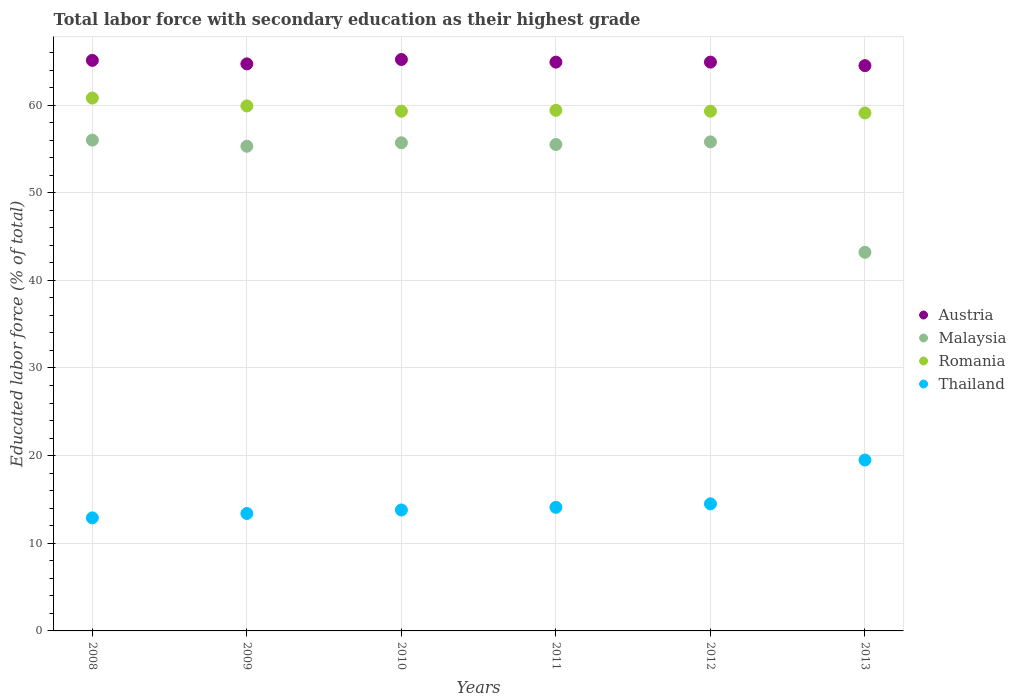How many different coloured dotlines are there?
Your answer should be very brief. 4. What is the percentage of total labor force with primary education in Thailand in 2013?
Keep it short and to the point. 19.5. Across all years, what is the maximum percentage of total labor force with primary education in Romania?
Ensure brevity in your answer.  60.8. Across all years, what is the minimum percentage of total labor force with primary education in Austria?
Offer a very short reply. 64.5. In which year was the percentage of total labor force with primary education in Austria minimum?
Provide a succinct answer. 2013. What is the total percentage of total labor force with primary education in Malaysia in the graph?
Give a very brief answer. 321.5. What is the difference between the percentage of total labor force with primary education in Thailand in 2008 and that in 2013?
Your answer should be compact. -6.6. What is the difference between the percentage of total labor force with primary education in Austria in 2011 and the percentage of total labor force with primary education in Thailand in 2008?
Give a very brief answer. 52. What is the average percentage of total labor force with primary education in Thailand per year?
Provide a short and direct response. 14.7. In the year 2012, what is the difference between the percentage of total labor force with primary education in Malaysia and percentage of total labor force with primary education in Thailand?
Offer a terse response. 41.3. What is the ratio of the percentage of total labor force with primary education in Malaysia in 2010 to that in 2012?
Your answer should be compact. 1. What is the difference between the highest and the second highest percentage of total labor force with primary education in Austria?
Offer a terse response. 0.1. What is the difference between the highest and the lowest percentage of total labor force with primary education in Romania?
Provide a succinct answer. 1.7. Is the sum of the percentage of total labor force with primary education in Romania in 2011 and 2012 greater than the maximum percentage of total labor force with primary education in Thailand across all years?
Offer a very short reply. Yes. Is it the case that in every year, the sum of the percentage of total labor force with primary education in Thailand and percentage of total labor force with primary education in Austria  is greater than the percentage of total labor force with primary education in Malaysia?
Your answer should be compact. Yes. Is the percentage of total labor force with primary education in Malaysia strictly greater than the percentage of total labor force with primary education in Austria over the years?
Your answer should be very brief. No. How many dotlines are there?
Provide a succinct answer. 4. How many legend labels are there?
Keep it short and to the point. 4. What is the title of the graph?
Give a very brief answer. Total labor force with secondary education as their highest grade. What is the label or title of the X-axis?
Make the answer very short. Years. What is the label or title of the Y-axis?
Provide a short and direct response. Educated labor force (% of total). What is the Educated labor force (% of total) of Austria in 2008?
Provide a succinct answer. 65.1. What is the Educated labor force (% of total) in Malaysia in 2008?
Your response must be concise. 56. What is the Educated labor force (% of total) of Romania in 2008?
Provide a succinct answer. 60.8. What is the Educated labor force (% of total) in Thailand in 2008?
Provide a succinct answer. 12.9. What is the Educated labor force (% of total) of Austria in 2009?
Your answer should be very brief. 64.7. What is the Educated labor force (% of total) in Malaysia in 2009?
Provide a succinct answer. 55.3. What is the Educated labor force (% of total) in Romania in 2009?
Ensure brevity in your answer.  59.9. What is the Educated labor force (% of total) of Thailand in 2009?
Offer a terse response. 13.4. What is the Educated labor force (% of total) of Austria in 2010?
Your answer should be compact. 65.2. What is the Educated labor force (% of total) of Malaysia in 2010?
Provide a short and direct response. 55.7. What is the Educated labor force (% of total) in Romania in 2010?
Provide a short and direct response. 59.3. What is the Educated labor force (% of total) of Thailand in 2010?
Your answer should be very brief. 13.8. What is the Educated labor force (% of total) of Austria in 2011?
Your response must be concise. 64.9. What is the Educated labor force (% of total) of Malaysia in 2011?
Ensure brevity in your answer.  55.5. What is the Educated labor force (% of total) of Romania in 2011?
Offer a terse response. 59.4. What is the Educated labor force (% of total) of Thailand in 2011?
Provide a short and direct response. 14.1. What is the Educated labor force (% of total) in Austria in 2012?
Ensure brevity in your answer.  64.9. What is the Educated labor force (% of total) of Malaysia in 2012?
Offer a terse response. 55.8. What is the Educated labor force (% of total) in Romania in 2012?
Keep it short and to the point. 59.3. What is the Educated labor force (% of total) in Austria in 2013?
Your answer should be very brief. 64.5. What is the Educated labor force (% of total) in Malaysia in 2013?
Your answer should be compact. 43.2. What is the Educated labor force (% of total) of Romania in 2013?
Give a very brief answer. 59.1. What is the Educated labor force (% of total) of Thailand in 2013?
Provide a short and direct response. 19.5. Across all years, what is the maximum Educated labor force (% of total) of Austria?
Your response must be concise. 65.2. Across all years, what is the maximum Educated labor force (% of total) of Romania?
Your answer should be compact. 60.8. Across all years, what is the maximum Educated labor force (% of total) of Thailand?
Offer a terse response. 19.5. Across all years, what is the minimum Educated labor force (% of total) in Austria?
Keep it short and to the point. 64.5. Across all years, what is the minimum Educated labor force (% of total) of Malaysia?
Provide a short and direct response. 43.2. Across all years, what is the minimum Educated labor force (% of total) in Romania?
Give a very brief answer. 59.1. Across all years, what is the minimum Educated labor force (% of total) of Thailand?
Your answer should be very brief. 12.9. What is the total Educated labor force (% of total) in Austria in the graph?
Your response must be concise. 389.3. What is the total Educated labor force (% of total) in Malaysia in the graph?
Provide a succinct answer. 321.5. What is the total Educated labor force (% of total) in Romania in the graph?
Give a very brief answer. 357.8. What is the total Educated labor force (% of total) in Thailand in the graph?
Keep it short and to the point. 88.2. What is the difference between the Educated labor force (% of total) of Malaysia in 2008 and that in 2009?
Your answer should be compact. 0.7. What is the difference between the Educated labor force (% of total) of Austria in 2008 and that in 2010?
Offer a very short reply. -0.1. What is the difference between the Educated labor force (% of total) in Austria in 2008 and that in 2011?
Give a very brief answer. 0.2. What is the difference between the Educated labor force (% of total) of Malaysia in 2008 and that in 2011?
Offer a terse response. 0.5. What is the difference between the Educated labor force (% of total) in Austria in 2008 and that in 2012?
Offer a very short reply. 0.2. What is the difference between the Educated labor force (% of total) in Romania in 2008 and that in 2012?
Your answer should be very brief. 1.5. What is the difference between the Educated labor force (% of total) in Austria in 2008 and that in 2013?
Your answer should be compact. 0.6. What is the difference between the Educated labor force (% of total) of Malaysia in 2008 and that in 2013?
Make the answer very short. 12.8. What is the difference between the Educated labor force (% of total) in Romania in 2009 and that in 2010?
Ensure brevity in your answer.  0.6. What is the difference between the Educated labor force (% of total) in Austria in 2009 and that in 2011?
Provide a short and direct response. -0.2. What is the difference between the Educated labor force (% of total) in Malaysia in 2009 and that in 2011?
Your response must be concise. -0.2. What is the difference between the Educated labor force (% of total) of Thailand in 2009 and that in 2011?
Offer a terse response. -0.7. What is the difference between the Educated labor force (% of total) of Malaysia in 2009 and that in 2012?
Offer a terse response. -0.5. What is the difference between the Educated labor force (% of total) of Austria in 2009 and that in 2013?
Offer a very short reply. 0.2. What is the difference between the Educated labor force (% of total) in Romania in 2009 and that in 2013?
Provide a short and direct response. 0.8. What is the difference between the Educated labor force (% of total) of Thailand in 2009 and that in 2013?
Make the answer very short. -6.1. What is the difference between the Educated labor force (% of total) of Romania in 2010 and that in 2011?
Keep it short and to the point. -0.1. What is the difference between the Educated labor force (% of total) in Thailand in 2010 and that in 2011?
Offer a terse response. -0.3. What is the difference between the Educated labor force (% of total) of Romania in 2010 and that in 2012?
Ensure brevity in your answer.  0. What is the difference between the Educated labor force (% of total) in Austria in 2010 and that in 2013?
Provide a short and direct response. 0.7. What is the difference between the Educated labor force (% of total) of Malaysia in 2010 and that in 2013?
Provide a succinct answer. 12.5. What is the difference between the Educated labor force (% of total) in Austria in 2011 and that in 2012?
Your response must be concise. 0. What is the difference between the Educated labor force (% of total) of Malaysia in 2011 and that in 2012?
Your response must be concise. -0.3. What is the difference between the Educated labor force (% of total) of Thailand in 2011 and that in 2012?
Make the answer very short. -0.4. What is the difference between the Educated labor force (% of total) of Austria in 2011 and that in 2013?
Your answer should be very brief. 0.4. What is the difference between the Educated labor force (% of total) in Malaysia in 2011 and that in 2013?
Provide a succinct answer. 12.3. What is the difference between the Educated labor force (% of total) of Thailand in 2011 and that in 2013?
Provide a short and direct response. -5.4. What is the difference between the Educated labor force (% of total) in Austria in 2008 and the Educated labor force (% of total) in Thailand in 2009?
Give a very brief answer. 51.7. What is the difference between the Educated labor force (% of total) of Malaysia in 2008 and the Educated labor force (% of total) of Romania in 2009?
Keep it short and to the point. -3.9. What is the difference between the Educated labor force (% of total) in Malaysia in 2008 and the Educated labor force (% of total) in Thailand in 2009?
Your answer should be very brief. 42.6. What is the difference between the Educated labor force (% of total) in Romania in 2008 and the Educated labor force (% of total) in Thailand in 2009?
Provide a short and direct response. 47.4. What is the difference between the Educated labor force (% of total) in Austria in 2008 and the Educated labor force (% of total) in Romania in 2010?
Your answer should be very brief. 5.8. What is the difference between the Educated labor force (% of total) in Austria in 2008 and the Educated labor force (% of total) in Thailand in 2010?
Offer a terse response. 51.3. What is the difference between the Educated labor force (% of total) in Malaysia in 2008 and the Educated labor force (% of total) in Romania in 2010?
Offer a very short reply. -3.3. What is the difference between the Educated labor force (% of total) of Malaysia in 2008 and the Educated labor force (% of total) of Thailand in 2010?
Ensure brevity in your answer.  42.2. What is the difference between the Educated labor force (% of total) in Austria in 2008 and the Educated labor force (% of total) in Malaysia in 2011?
Your answer should be very brief. 9.6. What is the difference between the Educated labor force (% of total) in Austria in 2008 and the Educated labor force (% of total) in Romania in 2011?
Give a very brief answer. 5.7. What is the difference between the Educated labor force (% of total) in Malaysia in 2008 and the Educated labor force (% of total) in Thailand in 2011?
Give a very brief answer. 41.9. What is the difference between the Educated labor force (% of total) of Romania in 2008 and the Educated labor force (% of total) of Thailand in 2011?
Offer a terse response. 46.7. What is the difference between the Educated labor force (% of total) of Austria in 2008 and the Educated labor force (% of total) of Romania in 2012?
Your answer should be very brief. 5.8. What is the difference between the Educated labor force (% of total) of Austria in 2008 and the Educated labor force (% of total) of Thailand in 2012?
Your answer should be very brief. 50.6. What is the difference between the Educated labor force (% of total) in Malaysia in 2008 and the Educated labor force (% of total) in Thailand in 2012?
Your response must be concise. 41.5. What is the difference between the Educated labor force (% of total) in Romania in 2008 and the Educated labor force (% of total) in Thailand in 2012?
Your response must be concise. 46.3. What is the difference between the Educated labor force (% of total) of Austria in 2008 and the Educated labor force (% of total) of Malaysia in 2013?
Your answer should be compact. 21.9. What is the difference between the Educated labor force (% of total) in Austria in 2008 and the Educated labor force (% of total) in Thailand in 2013?
Offer a terse response. 45.6. What is the difference between the Educated labor force (% of total) in Malaysia in 2008 and the Educated labor force (% of total) in Romania in 2013?
Offer a very short reply. -3.1. What is the difference between the Educated labor force (% of total) of Malaysia in 2008 and the Educated labor force (% of total) of Thailand in 2013?
Ensure brevity in your answer.  36.5. What is the difference between the Educated labor force (% of total) in Romania in 2008 and the Educated labor force (% of total) in Thailand in 2013?
Offer a terse response. 41.3. What is the difference between the Educated labor force (% of total) of Austria in 2009 and the Educated labor force (% of total) of Thailand in 2010?
Your answer should be very brief. 50.9. What is the difference between the Educated labor force (% of total) in Malaysia in 2009 and the Educated labor force (% of total) in Thailand in 2010?
Your response must be concise. 41.5. What is the difference between the Educated labor force (% of total) of Romania in 2009 and the Educated labor force (% of total) of Thailand in 2010?
Provide a succinct answer. 46.1. What is the difference between the Educated labor force (% of total) in Austria in 2009 and the Educated labor force (% of total) in Thailand in 2011?
Ensure brevity in your answer.  50.6. What is the difference between the Educated labor force (% of total) of Malaysia in 2009 and the Educated labor force (% of total) of Romania in 2011?
Provide a succinct answer. -4.1. What is the difference between the Educated labor force (% of total) of Malaysia in 2009 and the Educated labor force (% of total) of Thailand in 2011?
Your answer should be very brief. 41.2. What is the difference between the Educated labor force (% of total) of Romania in 2009 and the Educated labor force (% of total) of Thailand in 2011?
Keep it short and to the point. 45.8. What is the difference between the Educated labor force (% of total) of Austria in 2009 and the Educated labor force (% of total) of Malaysia in 2012?
Your answer should be very brief. 8.9. What is the difference between the Educated labor force (% of total) of Austria in 2009 and the Educated labor force (% of total) of Thailand in 2012?
Ensure brevity in your answer.  50.2. What is the difference between the Educated labor force (% of total) of Malaysia in 2009 and the Educated labor force (% of total) of Thailand in 2012?
Offer a very short reply. 40.8. What is the difference between the Educated labor force (% of total) in Romania in 2009 and the Educated labor force (% of total) in Thailand in 2012?
Your response must be concise. 45.4. What is the difference between the Educated labor force (% of total) of Austria in 2009 and the Educated labor force (% of total) of Thailand in 2013?
Ensure brevity in your answer.  45.2. What is the difference between the Educated labor force (% of total) of Malaysia in 2009 and the Educated labor force (% of total) of Romania in 2013?
Keep it short and to the point. -3.8. What is the difference between the Educated labor force (% of total) in Malaysia in 2009 and the Educated labor force (% of total) in Thailand in 2013?
Give a very brief answer. 35.8. What is the difference between the Educated labor force (% of total) in Romania in 2009 and the Educated labor force (% of total) in Thailand in 2013?
Offer a terse response. 40.4. What is the difference between the Educated labor force (% of total) of Austria in 2010 and the Educated labor force (% of total) of Thailand in 2011?
Your response must be concise. 51.1. What is the difference between the Educated labor force (% of total) of Malaysia in 2010 and the Educated labor force (% of total) of Thailand in 2011?
Make the answer very short. 41.6. What is the difference between the Educated labor force (% of total) in Romania in 2010 and the Educated labor force (% of total) in Thailand in 2011?
Your answer should be very brief. 45.2. What is the difference between the Educated labor force (% of total) in Austria in 2010 and the Educated labor force (% of total) in Thailand in 2012?
Make the answer very short. 50.7. What is the difference between the Educated labor force (% of total) of Malaysia in 2010 and the Educated labor force (% of total) of Thailand in 2012?
Make the answer very short. 41.2. What is the difference between the Educated labor force (% of total) of Romania in 2010 and the Educated labor force (% of total) of Thailand in 2012?
Give a very brief answer. 44.8. What is the difference between the Educated labor force (% of total) of Austria in 2010 and the Educated labor force (% of total) of Romania in 2013?
Keep it short and to the point. 6.1. What is the difference between the Educated labor force (% of total) in Austria in 2010 and the Educated labor force (% of total) in Thailand in 2013?
Keep it short and to the point. 45.7. What is the difference between the Educated labor force (% of total) of Malaysia in 2010 and the Educated labor force (% of total) of Thailand in 2013?
Offer a terse response. 36.2. What is the difference between the Educated labor force (% of total) of Romania in 2010 and the Educated labor force (% of total) of Thailand in 2013?
Offer a terse response. 39.8. What is the difference between the Educated labor force (% of total) in Austria in 2011 and the Educated labor force (% of total) in Malaysia in 2012?
Keep it short and to the point. 9.1. What is the difference between the Educated labor force (% of total) in Austria in 2011 and the Educated labor force (% of total) in Thailand in 2012?
Your answer should be compact. 50.4. What is the difference between the Educated labor force (% of total) in Romania in 2011 and the Educated labor force (% of total) in Thailand in 2012?
Give a very brief answer. 44.9. What is the difference between the Educated labor force (% of total) of Austria in 2011 and the Educated labor force (% of total) of Malaysia in 2013?
Keep it short and to the point. 21.7. What is the difference between the Educated labor force (% of total) in Austria in 2011 and the Educated labor force (% of total) in Thailand in 2013?
Give a very brief answer. 45.4. What is the difference between the Educated labor force (% of total) in Romania in 2011 and the Educated labor force (% of total) in Thailand in 2013?
Your answer should be compact. 39.9. What is the difference between the Educated labor force (% of total) in Austria in 2012 and the Educated labor force (% of total) in Malaysia in 2013?
Offer a terse response. 21.7. What is the difference between the Educated labor force (% of total) of Austria in 2012 and the Educated labor force (% of total) of Romania in 2013?
Your answer should be very brief. 5.8. What is the difference between the Educated labor force (% of total) in Austria in 2012 and the Educated labor force (% of total) in Thailand in 2013?
Make the answer very short. 45.4. What is the difference between the Educated labor force (% of total) of Malaysia in 2012 and the Educated labor force (% of total) of Romania in 2013?
Your answer should be compact. -3.3. What is the difference between the Educated labor force (% of total) of Malaysia in 2012 and the Educated labor force (% of total) of Thailand in 2013?
Offer a very short reply. 36.3. What is the difference between the Educated labor force (% of total) of Romania in 2012 and the Educated labor force (% of total) of Thailand in 2013?
Provide a succinct answer. 39.8. What is the average Educated labor force (% of total) of Austria per year?
Make the answer very short. 64.88. What is the average Educated labor force (% of total) of Malaysia per year?
Make the answer very short. 53.58. What is the average Educated labor force (% of total) of Romania per year?
Give a very brief answer. 59.63. In the year 2008, what is the difference between the Educated labor force (% of total) of Austria and Educated labor force (% of total) of Malaysia?
Keep it short and to the point. 9.1. In the year 2008, what is the difference between the Educated labor force (% of total) of Austria and Educated labor force (% of total) of Romania?
Your answer should be compact. 4.3. In the year 2008, what is the difference between the Educated labor force (% of total) in Austria and Educated labor force (% of total) in Thailand?
Your answer should be compact. 52.2. In the year 2008, what is the difference between the Educated labor force (% of total) of Malaysia and Educated labor force (% of total) of Romania?
Ensure brevity in your answer.  -4.8. In the year 2008, what is the difference between the Educated labor force (% of total) of Malaysia and Educated labor force (% of total) of Thailand?
Provide a succinct answer. 43.1. In the year 2008, what is the difference between the Educated labor force (% of total) of Romania and Educated labor force (% of total) of Thailand?
Offer a terse response. 47.9. In the year 2009, what is the difference between the Educated labor force (% of total) in Austria and Educated labor force (% of total) in Romania?
Offer a terse response. 4.8. In the year 2009, what is the difference between the Educated labor force (% of total) of Austria and Educated labor force (% of total) of Thailand?
Keep it short and to the point. 51.3. In the year 2009, what is the difference between the Educated labor force (% of total) in Malaysia and Educated labor force (% of total) in Thailand?
Offer a terse response. 41.9. In the year 2009, what is the difference between the Educated labor force (% of total) of Romania and Educated labor force (% of total) of Thailand?
Your answer should be compact. 46.5. In the year 2010, what is the difference between the Educated labor force (% of total) in Austria and Educated labor force (% of total) in Malaysia?
Give a very brief answer. 9.5. In the year 2010, what is the difference between the Educated labor force (% of total) in Austria and Educated labor force (% of total) in Romania?
Provide a succinct answer. 5.9. In the year 2010, what is the difference between the Educated labor force (% of total) of Austria and Educated labor force (% of total) of Thailand?
Your answer should be very brief. 51.4. In the year 2010, what is the difference between the Educated labor force (% of total) in Malaysia and Educated labor force (% of total) in Romania?
Keep it short and to the point. -3.6. In the year 2010, what is the difference between the Educated labor force (% of total) of Malaysia and Educated labor force (% of total) of Thailand?
Offer a very short reply. 41.9. In the year 2010, what is the difference between the Educated labor force (% of total) of Romania and Educated labor force (% of total) of Thailand?
Provide a succinct answer. 45.5. In the year 2011, what is the difference between the Educated labor force (% of total) of Austria and Educated labor force (% of total) of Romania?
Provide a short and direct response. 5.5. In the year 2011, what is the difference between the Educated labor force (% of total) of Austria and Educated labor force (% of total) of Thailand?
Give a very brief answer. 50.8. In the year 2011, what is the difference between the Educated labor force (% of total) of Malaysia and Educated labor force (% of total) of Thailand?
Your response must be concise. 41.4. In the year 2011, what is the difference between the Educated labor force (% of total) of Romania and Educated labor force (% of total) of Thailand?
Ensure brevity in your answer.  45.3. In the year 2012, what is the difference between the Educated labor force (% of total) in Austria and Educated labor force (% of total) in Malaysia?
Offer a very short reply. 9.1. In the year 2012, what is the difference between the Educated labor force (% of total) of Austria and Educated labor force (% of total) of Romania?
Your answer should be very brief. 5.6. In the year 2012, what is the difference between the Educated labor force (% of total) of Austria and Educated labor force (% of total) of Thailand?
Make the answer very short. 50.4. In the year 2012, what is the difference between the Educated labor force (% of total) in Malaysia and Educated labor force (% of total) in Romania?
Your answer should be very brief. -3.5. In the year 2012, what is the difference between the Educated labor force (% of total) of Malaysia and Educated labor force (% of total) of Thailand?
Keep it short and to the point. 41.3. In the year 2012, what is the difference between the Educated labor force (% of total) of Romania and Educated labor force (% of total) of Thailand?
Your answer should be compact. 44.8. In the year 2013, what is the difference between the Educated labor force (% of total) of Austria and Educated labor force (% of total) of Malaysia?
Your answer should be very brief. 21.3. In the year 2013, what is the difference between the Educated labor force (% of total) of Austria and Educated labor force (% of total) of Thailand?
Give a very brief answer. 45. In the year 2013, what is the difference between the Educated labor force (% of total) of Malaysia and Educated labor force (% of total) of Romania?
Offer a very short reply. -15.9. In the year 2013, what is the difference between the Educated labor force (% of total) of Malaysia and Educated labor force (% of total) of Thailand?
Give a very brief answer. 23.7. In the year 2013, what is the difference between the Educated labor force (% of total) of Romania and Educated labor force (% of total) of Thailand?
Provide a succinct answer. 39.6. What is the ratio of the Educated labor force (% of total) in Malaysia in 2008 to that in 2009?
Your response must be concise. 1.01. What is the ratio of the Educated labor force (% of total) in Romania in 2008 to that in 2009?
Give a very brief answer. 1.01. What is the ratio of the Educated labor force (% of total) in Thailand in 2008 to that in 2009?
Provide a succinct answer. 0.96. What is the ratio of the Educated labor force (% of total) of Austria in 2008 to that in 2010?
Provide a short and direct response. 1. What is the ratio of the Educated labor force (% of total) in Malaysia in 2008 to that in 2010?
Make the answer very short. 1.01. What is the ratio of the Educated labor force (% of total) of Romania in 2008 to that in 2010?
Your answer should be very brief. 1.03. What is the ratio of the Educated labor force (% of total) in Thailand in 2008 to that in 2010?
Keep it short and to the point. 0.93. What is the ratio of the Educated labor force (% of total) in Austria in 2008 to that in 2011?
Your answer should be compact. 1. What is the ratio of the Educated labor force (% of total) of Romania in 2008 to that in 2011?
Keep it short and to the point. 1.02. What is the ratio of the Educated labor force (% of total) in Thailand in 2008 to that in 2011?
Keep it short and to the point. 0.91. What is the ratio of the Educated labor force (% of total) of Romania in 2008 to that in 2012?
Make the answer very short. 1.03. What is the ratio of the Educated labor force (% of total) in Thailand in 2008 to that in 2012?
Your answer should be very brief. 0.89. What is the ratio of the Educated labor force (% of total) of Austria in 2008 to that in 2013?
Keep it short and to the point. 1.01. What is the ratio of the Educated labor force (% of total) of Malaysia in 2008 to that in 2013?
Offer a very short reply. 1.3. What is the ratio of the Educated labor force (% of total) of Romania in 2008 to that in 2013?
Provide a succinct answer. 1.03. What is the ratio of the Educated labor force (% of total) of Thailand in 2008 to that in 2013?
Provide a short and direct response. 0.66. What is the ratio of the Educated labor force (% of total) in Malaysia in 2009 to that in 2010?
Provide a short and direct response. 0.99. What is the ratio of the Educated labor force (% of total) of Thailand in 2009 to that in 2010?
Make the answer very short. 0.97. What is the ratio of the Educated labor force (% of total) in Austria in 2009 to that in 2011?
Provide a succinct answer. 1. What is the ratio of the Educated labor force (% of total) in Malaysia in 2009 to that in 2011?
Offer a terse response. 1. What is the ratio of the Educated labor force (% of total) in Romania in 2009 to that in 2011?
Your answer should be very brief. 1.01. What is the ratio of the Educated labor force (% of total) of Thailand in 2009 to that in 2011?
Your response must be concise. 0.95. What is the ratio of the Educated labor force (% of total) of Malaysia in 2009 to that in 2012?
Keep it short and to the point. 0.99. What is the ratio of the Educated labor force (% of total) in Romania in 2009 to that in 2012?
Offer a very short reply. 1.01. What is the ratio of the Educated labor force (% of total) of Thailand in 2009 to that in 2012?
Ensure brevity in your answer.  0.92. What is the ratio of the Educated labor force (% of total) in Malaysia in 2009 to that in 2013?
Keep it short and to the point. 1.28. What is the ratio of the Educated labor force (% of total) in Romania in 2009 to that in 2013?
Provide a short and direct response. 1.01. What is the ratio of the Educated labor force (% of total) of Thailand in 2009 to that in 2013?
Provide a short and direct response. 0.69. What is the ratio of the Educated labor force (% of total) of Malaysia in 2010 to that in 2011?
Provide a short and direct response. 1. What is the ratio of the Educated labor force (% of total) of Romania in 2010 to that in 2011?
Your answer should be very brief. 1. What is the ratio of the Educated labor force (% of total) in Thailand in 2010 to that in 2011?
Provide a succinct answer. 0.98. What is the ratio of the Educated labor force (% of total) of Austria in 2010 to that in 2012?
Keep it short and to the point. 1. What is the ratio of the Educated labor force (% of total) in Malaysia in 2010 to that in 2012?
Keep it short and to the point. 1. What is the ratio of the Educated labor force (% of total) in Romania in 2010 to that in 2012?
Offer a terse response. 1. What is the ratio of the Educated labor force (% of total) in Thailand in 2010 to that in 2012?
Provide a succinct answer. 0.95. What is the ratio of the Educated labor force (% of total) of Austria in 2010 to that in 2013?
Provide a short and direct response. 1.01. What is the ratio of the Educated labor force (% of total) of Malaysia in 2010 to that in 2013?
Give a very brief answer. 1.29. What is the ratio of the Educated labor force (% of total) of Romania in 2010 to that in 2013?
Offer a very short reply. 1. What is the ratio of the Educated labor force (% of total) of Thailand in 2010 to that in 2013?
Give a very brief answer. 0.71. What is the ratio of the Educated labor force (% of total) of Austria in 2011 to that in 2012?
Offer a terse response. 1. What is the ratio of the Educated labor force (% of total) of Thailand in 2011 to that in 2012?
Your answer should be compact. 0.97. What is the ratio of the Educated labor force (% of total) of Austria in 2011 to that in 2013?
Ensure brevity in your answer.  1.01. What is the ratio of the Educated labor force (% of total) in Malaysia in 2011 to that in 2013?
Keep it short and to the point. 1.28. What is the ratio of the Educated labor force (% of total) in Thailand in 2011 to that in 2013?
Provide a succinct answer. 0.72. What is the ratio of the Educated labor force (% of total) in Malaysia in 2012 to that in 2013?
Provide a succinct answer. 1.29. What is the ratio of the Educated labor force (% of total) in Thailand in 2012 to that in 2013?
Your answer should be compact. 0.74. What is the difference between the highest and the second highest Educated labor force (% of total) in Austria?
Provide a short and direct response. 0.1. What is the difference between the highest and the lowest Educated labor force (% of total) of Romania?
Offer a very short reply. 1.7. 